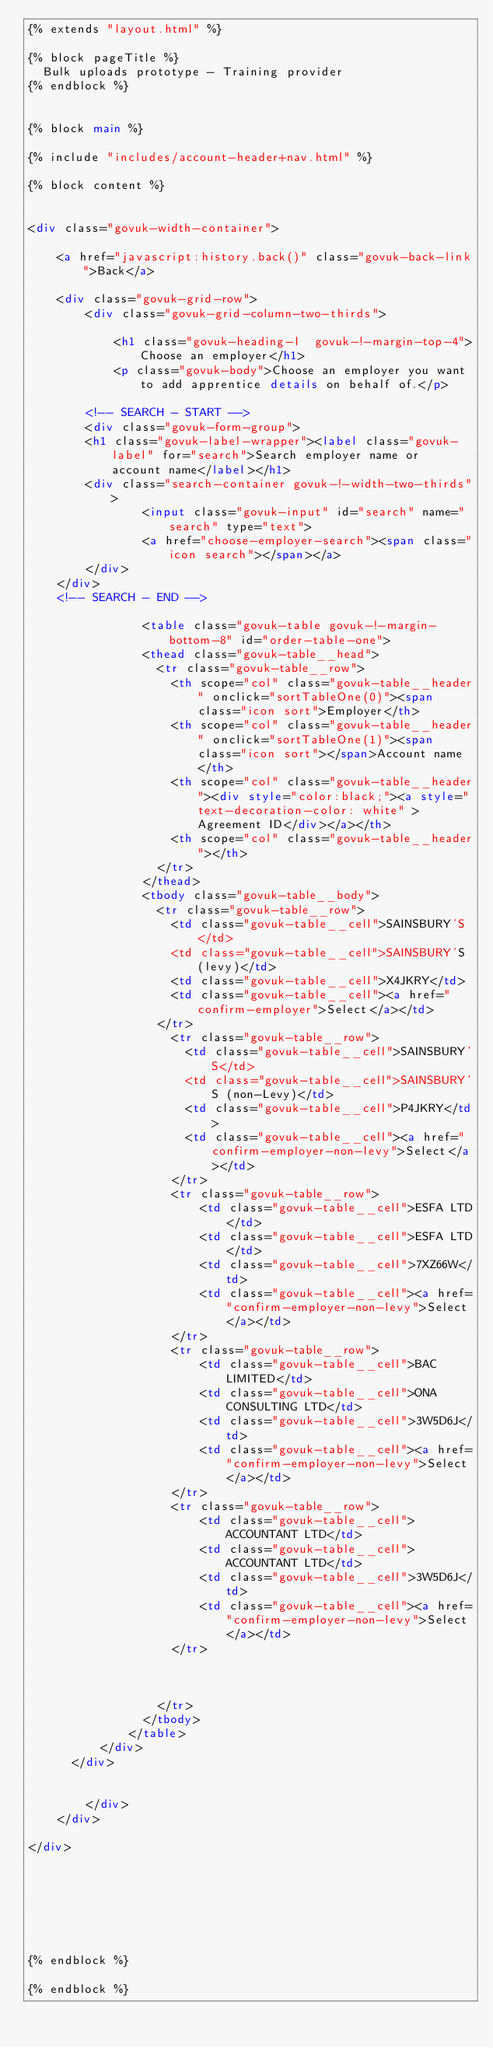Convert code to text. <code><loc_0><loc_0><loc_500><loc_500><_HTML_>{% extends "layout.html" %}

{% block pageTitle %}
  Bulk uploads prototype - Training provider
{% endblock %}


{% block main %}

{% include "includes/account-header+nav.html" %}

{% block content %}


<div class="govuk-width-container">
	
	<a href="javascript:history.back()" class="govuk-back-link">Back</a>

	<div class="govuk-grid-row">
		<div class="govuk-grid-column-two-thirds">
					    
		    <h1 class="govuk-heading-l  govuk-!-margin-top-4">Choose an employer</h1>		
			<p class="govuk-body">Choose an employer you want to add apprentice details on behalf of.</p> 

		<!-- SEARCH - START -->
		<div class="govuk-form-group">
		<h1 class="govuk-label-wrapper"><label class="govuk-label" for="search">Search employer name or account name</label></h1>
		<div class="search-container govuk-!-width-two-thirds">
				<input class="govuk-input" id="search" name="search" type="text">
				<a href="choose-employer-search"><span class="icon search"></span></a>
		</div>
	</div>
	<!-- SEARCH - END -->			
			  
				<table class="govuk-table govuk-!-margin-bottom-8" id="order-table-one">
				<thead class="govuk-table__head">
				  <tr class="govuk-table__row">
					<th scope="col" class="govuk-table__header" onclick="sortTableOne(0)"><span class="icon sort">Employer</th>
					<th scope="col" class="govuk-table__header" onclick="sortTableOne(1)"><span class="icon sort"></span>Account name</th>
					<th scope="col" class="govuk-table__header"><div style="color:black;"><a style="text-decoration-color: white" >Agreement ID</div></a></th>
					<th scope="col" class="govuk-table__header"></th>
				  </tr>
				</thead>
				<tbody class="govuk-table__body">
				  <tr class="govuk-table__row">
					<td class="govuk-table__cell">SAINSBURY'S</td>
					<td class="govuk-table__cell">SAINSBURY'S (levy)</td>
					<td class="govuk-table__cell">X4JKRY</td>
					<td class="govuk-table__cell"><a href="confirm-employer">Select</a></td>
				  </tr>
					<tr class="govuk-table__row">
					  <td class="govuk-table__cell">SAINSBURY'S</td>
					  <td class="govuk-table__cell">SAINSBURY'S (non-Levy)</td>
					  <td class="govuk-table__cell">P4JKRY</td>
					  <td class="govuk-table__cell"><a href="confirm-employer-non-levy">Select</a></td>
					</tr>
					<tr class="govuk-table__row">
						<td class="govuk-table__cell">ESFA LTD</td>
						<td class="govuk-table__cell">ESFA LTD</td>
						<td class="govuk-table__cell">7XZ66W</td>
						<td class="govuk-table__cell"><a href="confirm-employer-non-levy">Select</a></td>
					</tr>
					<tr class="govuk-table__row">
						<td class="govuk-table__cell">BAC LIMITED</td>
						<td class="govuk-table__cell">ONA CONSULTING LTD</td>
						<td class="govuk-table__cell">3W5D6J</td>
						<td class="govuk-table__cell"><a href="confirm-employer-non-levy">Select</a></td>
					</tr>
					<tr class="govuk-table__row">
						<td class="govuk-table__cell">ACCOUNTANT LTD</td>
						<td class="govuk-table__cell">ACCOUNTANT LTD</td>
						<td class="govuk-table__cell">3W5D6J</td>
						<td class="govuk-table__cell"><a href="confirm-employer-non-levy">Select</a></td>
					</tr>

  
  
				  </tr>
				</tbody>
			  </table>		
		  </div>
	  </div>
  
		    
	    </div>
	</div>
	
</div>	







{% endblock %}

{% endblock %}
</code> 